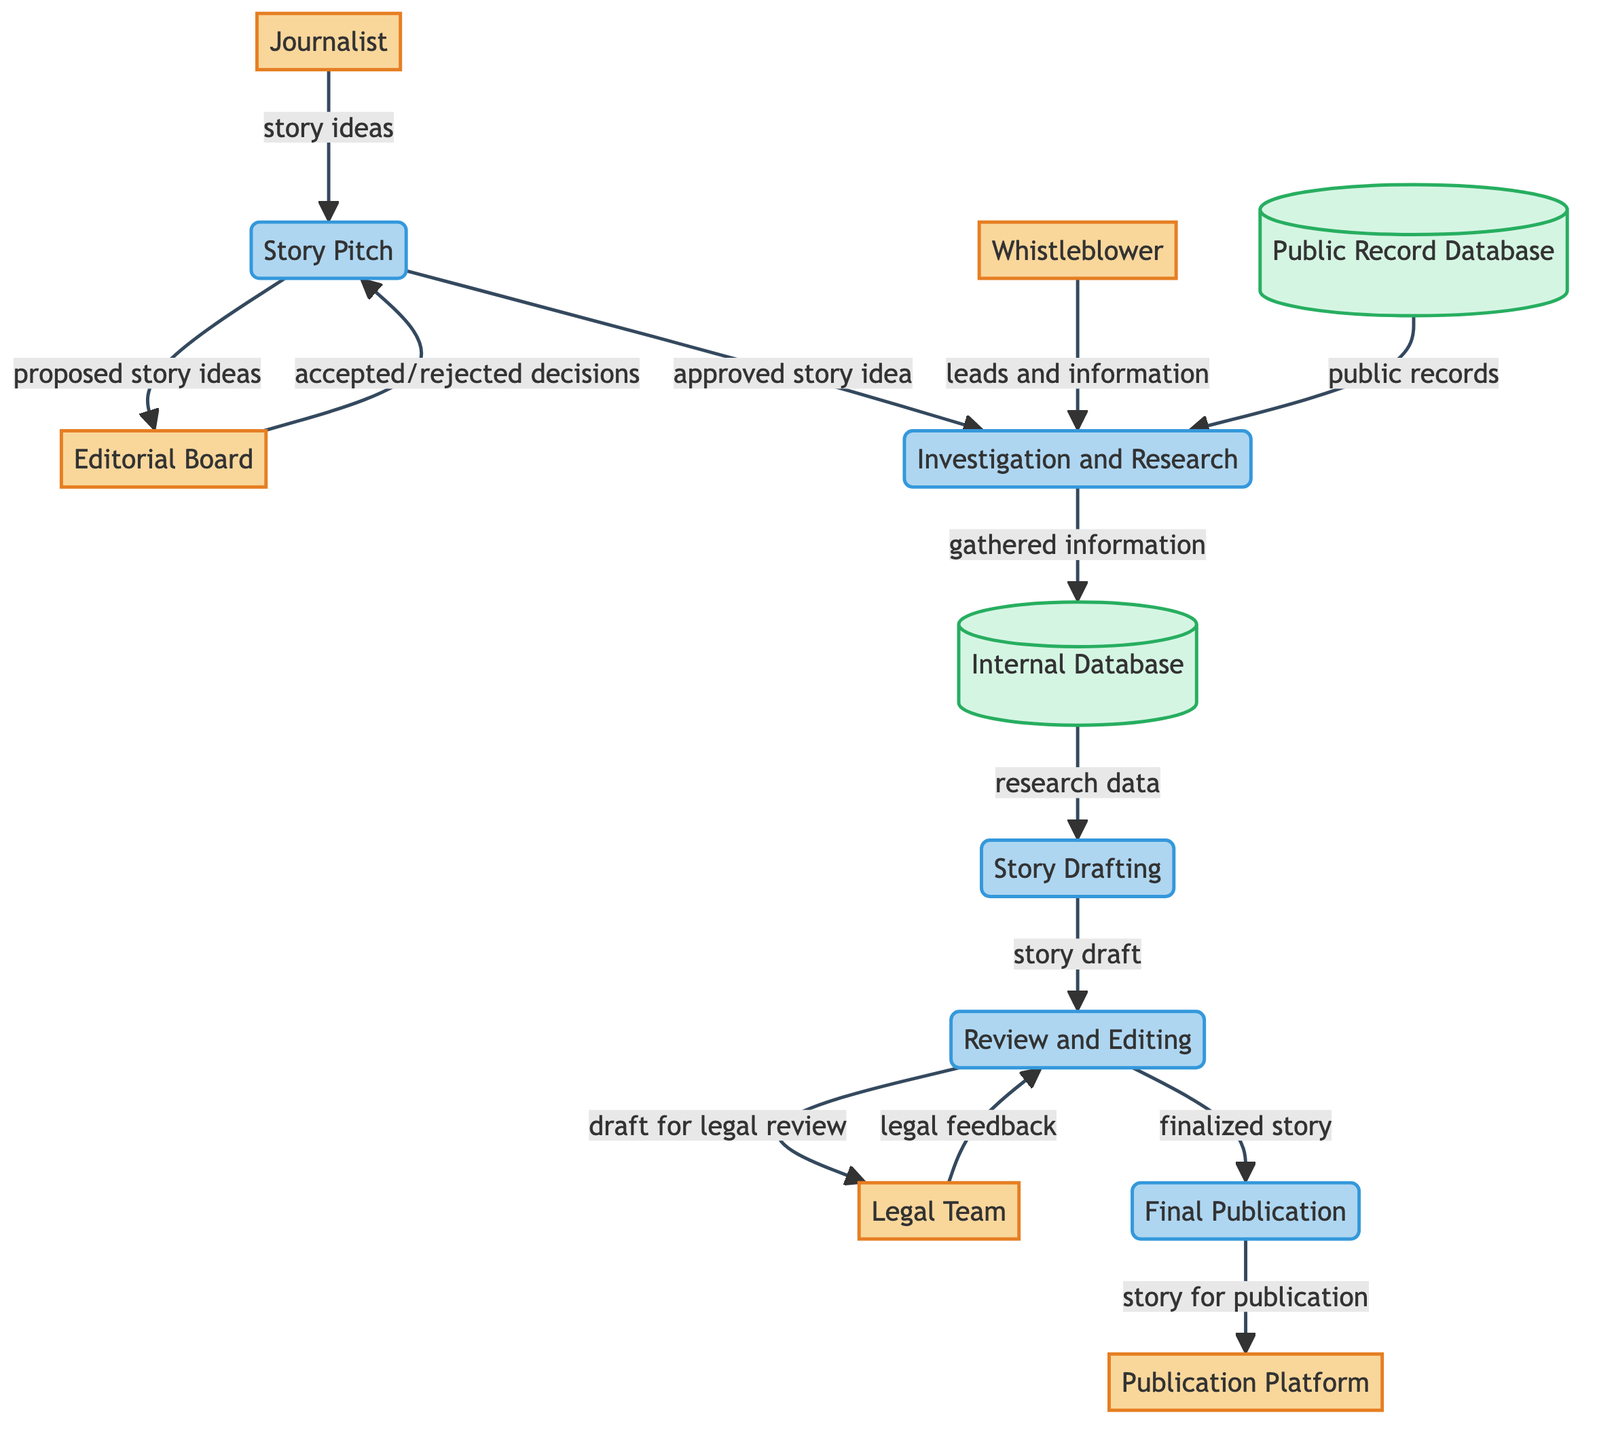What entity proposes story ideas? The entity that proposes story ideas is the Journalist, as indicated by the flow from the Journalist to the Story Pitch process in the diagram.
Answer: Journalist How many data stores are present in the diagram? The diagram contains two data stores: the Public Record Database and the Internal Database.
Answer: 2 What is the process after the Story Drafting? The process that follows Story Drafting is Review and Editing, as shown by the flow from Story Drafting to Review and Editing.
Answer: Review and Editing Who provides leads and information for the Investigation and Research process? The Whistleblower provides leads and information during the Investigation and Research process, as indicated by the arrow connecting Whistleblower to Investigation and Research.
Answer: Whistleblower What feedback does the Legal Team provide to Review and Editing? The Legal Team provides legal feedback to Review and Editing, as shown by the flow from Legal Team to Review and Editing.
Answer: Legal feedback What is the final process before publication? The final process before publication is Final Publication, which is the last step before the story is delivered to the Publication Platform.
Answer: Final Publication How does the Editorial Board interact with the Story Pitch? The Editorial Board interacts with the Story Pitch by sending accepted or rejected decisions back to the Story Pitch from the Editorial Board, indicating the approval or disapproval of the proposed story ideas.
Answer: Accepted/rejected decisions Which data store receives gathered information from Investigation and Research? The Internal Database receives gathered information from the Investigation and Research process, indicated by the flow from Investigation and Research to Internal Database.
Answer: Internal Database What type of diagram is represented here? The diagram represents a Data Flow Diagram, which illustrates how data flows through entities, processes, and data stores in the system.
Answer: Data Flow Diagram 